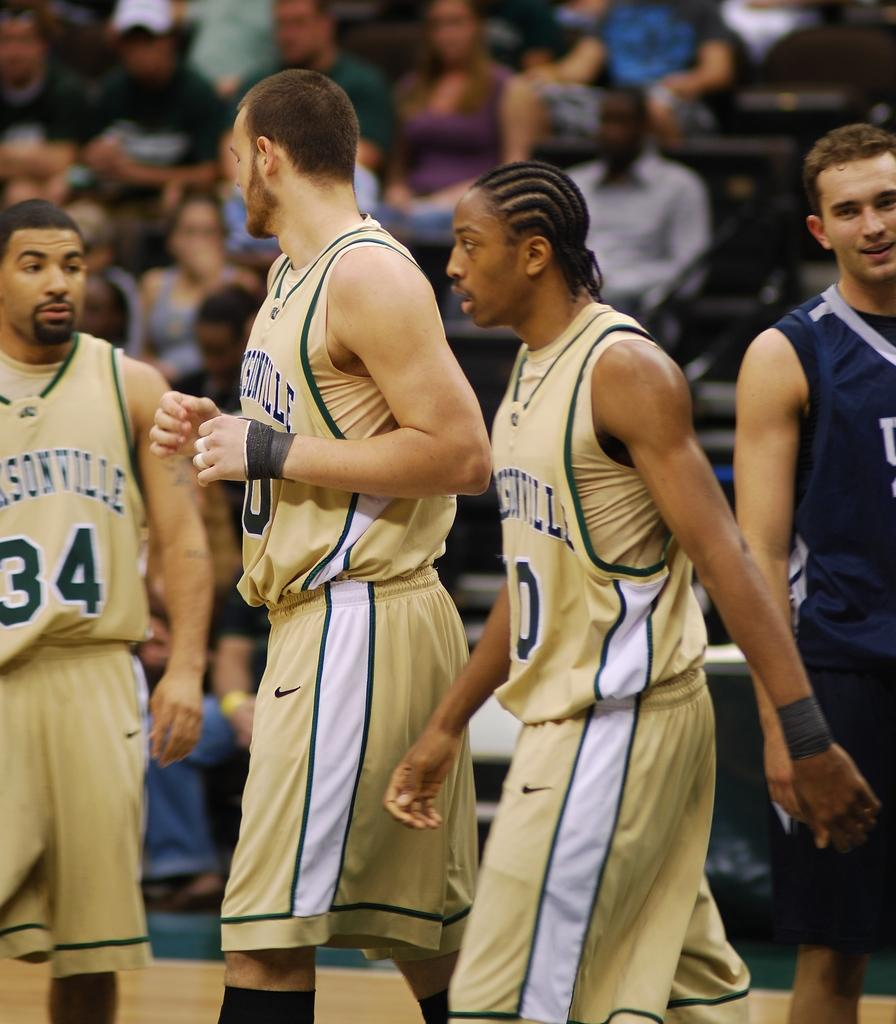Provide a one-sentence caption for the provided image. 3 Jacksonville basketball players are walking on the court. 